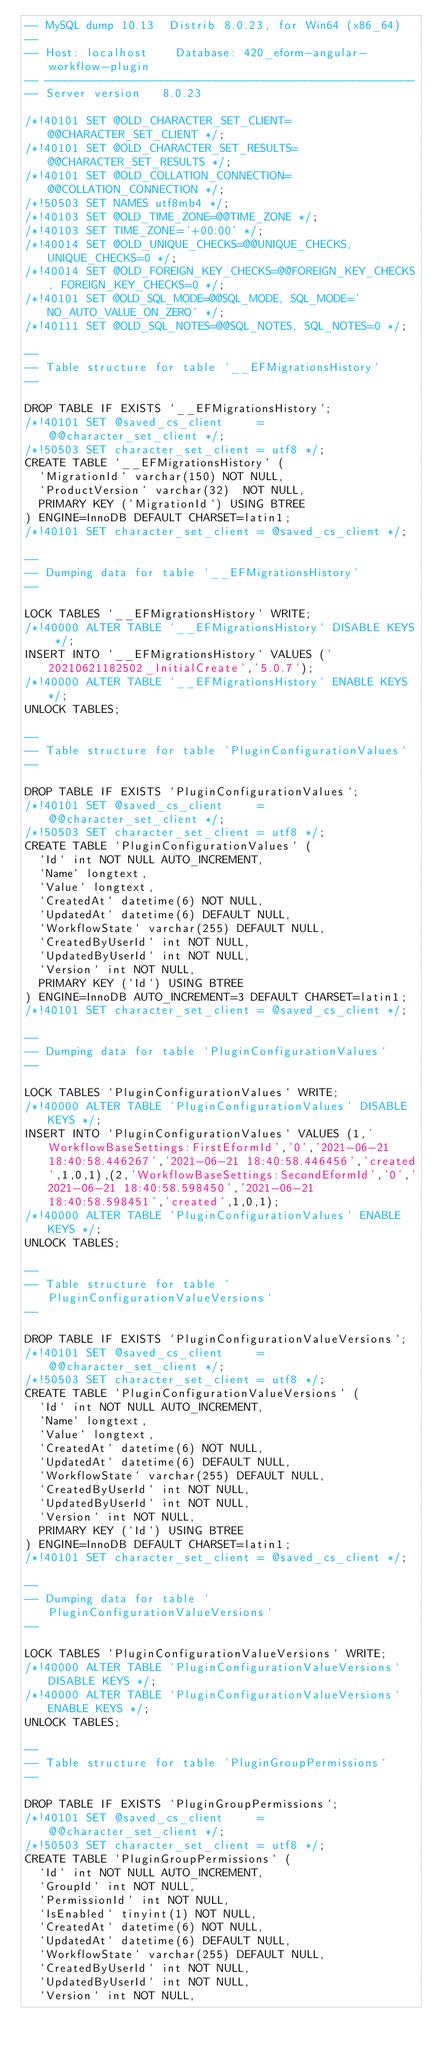Convert code to text. <code><loc_0><loc_0><loc_500><loc_500><_SQL_>-- MySQL dump 10.13  Distrib 8.0.23, for Win64 (x86_64)
--
-- Host: localhost    Database: 420_eform-angular-workflow-plugin
-- ------------------------------------------------------
-- Server version	8.0.23

/*!40101 SET @OLD_CHARACTER_SET_CLIENT=@@CHARACTER_SET_CLIENT */;
/*!40101 SET @OLD_CHARACTER_SET_RESULTS=@@CHARACTER_SET_RESULTS */;
/*!40101 SET @OLD_COLLATION_CONNECTION=@@COLLATION_CONNECTION */;
/*!50503 SET NAMES utf8mb4 */;
/*!40103 SET @OLD_TIME_ZONE=@@TIME_ZONE */;
/*!40103 SET TIME_ZONE='+00:00' */;
/*!40014 SET @OLD_UNIQUE_CHECKS=@@UNIQUE_CHECKS, UNIQUE_CHECKS=0 */;
/*!40014 SET @OLD_FOREIGN_KEY_CHECKS=@@FOREIGN_KEY_CHECKS, FOREIGN_KEY_CHECKS=0 */;
/*!40101 SET @OLD_SQL_MODE=@@SQL_MODE, SQL_MODE='NO_AUTO_VALUE_ON_ZERO' */;
/*!40111 SET @OLD_SQL_NOTES=@@SQL_NOTES, SQL_NOTES=0 */;

--
-- Table structure for table `__EFMigrationsHistory`
--

DROP TABLE IF EXISTS `__EFMigrationsHistory`;
/*!40101 SET @saved_cs_client     = @@character_set_client */;
/*!50503 SET character_set_client = utf8 */;
CREATE TABLE `__EFMigrationsHistory` (
  `MigrationId` varchar(150) NOT NULL,
  `ProductVersion` varchar(32)  NOT NULL,
  PRIMARY KEY (`MigrationId`) USING BTREE
) ENGINE=InnoDB DEFAULT CHARSET=latin1;
/*!40101 SET character_set_client = @saved_cs_client */;

--
-- Dumping data for table `__EFMigrationsHistory`
--

LOCK TABLES `__EFMigrationsHistory` WRITE;
/*!40000 ALTER TABLE `__EFMigrationsHistory` DISABLE KEYS */;
INSERT INTO `__EFMigrationsHistory` VALUES ('20210621182502_InitialCreate','5.0.7');
/*!40000 ALTER TABLE `__EFMigrationsHistory` ENABLE KEYS */;
UNLOCK TABLES;

--
-- Table structure for table `PluginConfigurationValues`
--

DROP TABLE IF EXISTS `PluginConfigurationValues`;
/*!40101 SET @saved_cs_client     = @@character_set_client */;
/*!50503 SET character_set_client = utf8 */;
CREATE TABLE `PluginConfigurationValues` (
  `Id` int NOT NULL AUTO_INCREMENT,
  `Name` longtext,
  `Value` longtext,
  `CreatedAt` datetime(6) NOT NULL,
  `UpdatedAt` datetime(6) DEFAULT NULL,
  `WorkflowState` varchar(255) DEFAULT NULL,
  `CreatedByUserId` int NOT NULL,
  `UpdatedByUserId` int NOT NULL,
  `Version` int NOT NULL,
  PRIMARY KEY (`Id`) USING BTREE
) ENGINE=InnoDB AUTO_INCREMENT=3 DEFAULT CHARSET=latin1;
/*!40101 SET character_set_client = @saved_cs_client */;

--
-- Dumping data for table `PluginConfigurationValues`
--

LOCK TABLES `PluginConfigurationValues` WRITE;
/*!40000 ALTER TABLE `PluginConfigurationValues` DISABLE KEYS */;
INSERT INTO `PluginConfigurationValues` VALUES (1,'WorkflowBaseSettings:FirstEformId','0','2021-06-21 18:40:58.446267','2021-06-21 18:40:58.446456','created',1,0,1),(2,'WorkflowBaseSettings:SecondEformId','0','2021-06-21 18:40:58.598450','2021-06-21 18:40:58.598451','created',1,0,1);
/*!40000 ALTER TABLE `PluginConfigurationValues` ENABLE KEYS */;
UNLOCK TABLES;

--
-- Table structure for table `PluginConfigurationValueVersions`
--

DROP TABLE IF EXISTS `PluginConfigurationValueVersions`;
/*!40101 SET @saved_cs_client     = @@character_set_client */;
/*!50503 SET character_set_client = utf8 */;
CREATE TABLE `PluginConfigurationValueVersions` (
  `Id` int NOT NULL AUTO_INCREMENT,
  `Name` longtext,
  `Value` longtext,
  `CreatedAt` datetime(6) NOT NULL,
  `UpdatedAt` datetime(6) DEFAULT NULL,
  `WorkflowState` varchar(255) DEFAULT NULL,
  `CreatedByUserId` int NOT NULL,
  `UpdatedByUserId` int NOT NULL,
  `Version` int NOT NULL,
  PRIMARY KEY (`Id`) USING BTREE
) ENGINE=InnoDB DEFAULT CHARSET=latin1;
/*!40101 SET character_set_client = @saved_cs_client */;

--
-- Dumping data for table `PluginConfigurationValueVersions`
--

LOCK TABLES `PluginConfigurationValueVersions` WRITE;
/*!40000 ALTER TABLE `PluginConfigurationValueVersions` DISABLE KEYS */;
/*!40000 ALTER TABLE `PluginConfigurationValueVersions` ENABLE KEYS */;
UNLOCK TABLES;

--
-- Table structure for table `PluginGroupPermissions`
--

DROP TABLE IF EXISTS `PluginGroupPermissions`;
/*!40101 SET @saved_cs_client     = @@character_set_client */;
/*!50503 SET character_set_client = utf8 */;
CREATE TABLE `PluginGroupPermissions` (
  `Id` int NOT NULL AUTO_INCREMENT,
  `GroupId` int NOT NULL,
  `PermissionId` int NOT NULL,
  `IsEnabled` tinyint(1) NOT NULL,
  `CreatedAt` datetime(6) NOT NULL,
  `UpdatedAt` datetime(6) DEFAULT NULL,
  `WorkflowState` varchar(255) DEFAULT NULL,
  `CreatedByUserId` int NOT NULL,
  `UpdatedByUserId` int NOT NULL,
  `Version` int NOT NULL,</code> 